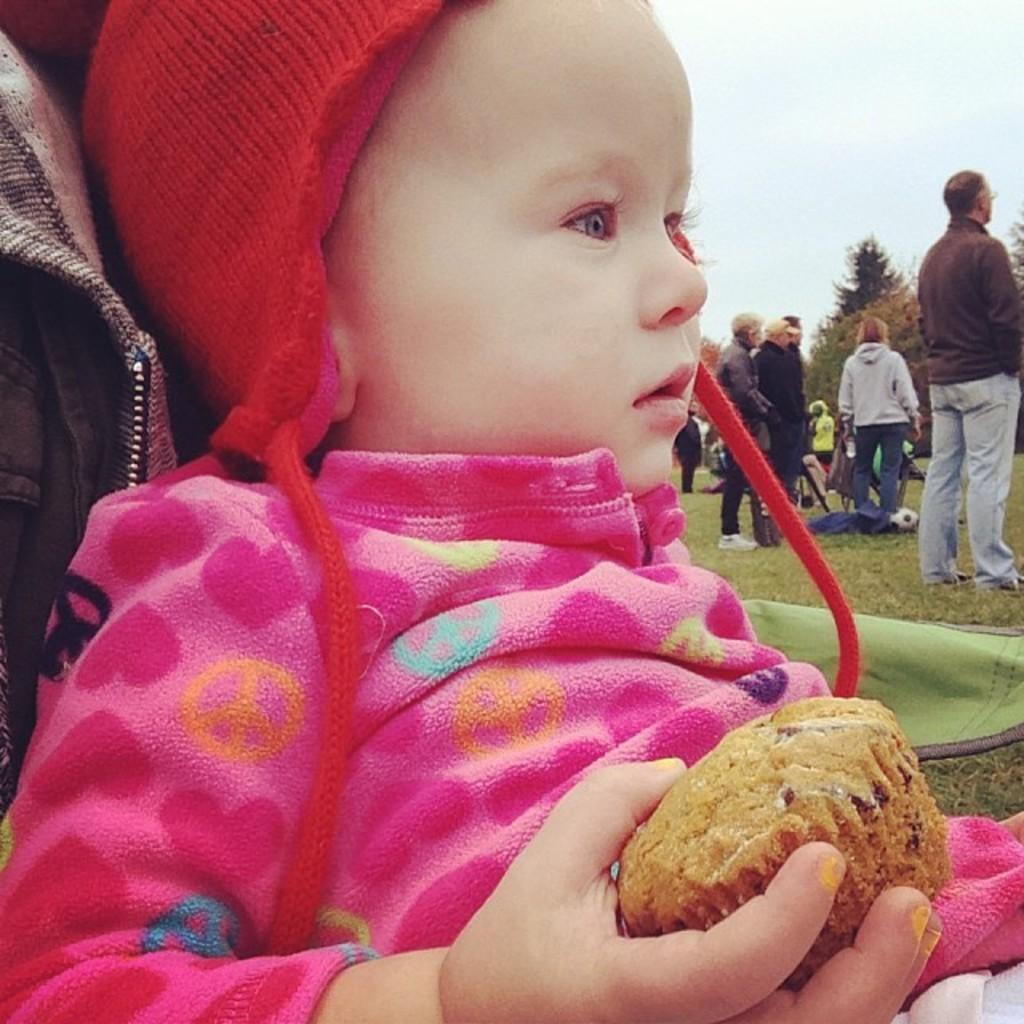What is the baby holding in the image? The baby is holding a cupcake in the image. What can be seen on the ground in the image? There are persons standing on the ground in the image. What type of vegetation is visible in the image? There are trees visible in the image. What is visible in the background of the image? The sky is visible in the image. What type of guitar is the governor playing in the image? There is no governor or guitar present in the image. 